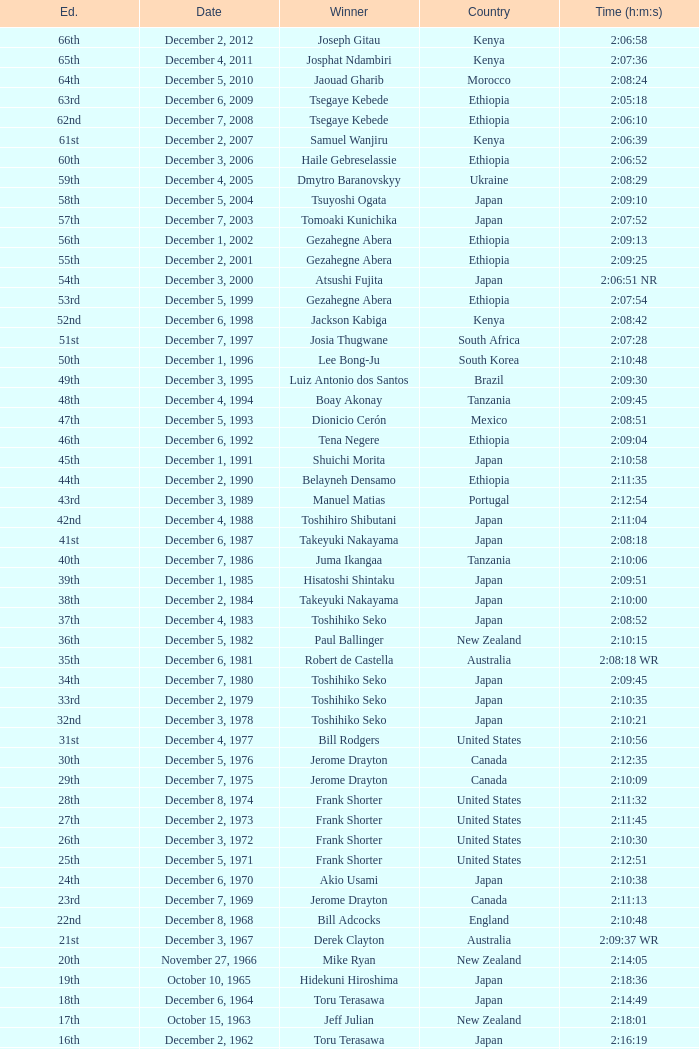Who was the winner of the 23rd Edition? Jerome Drayton. 